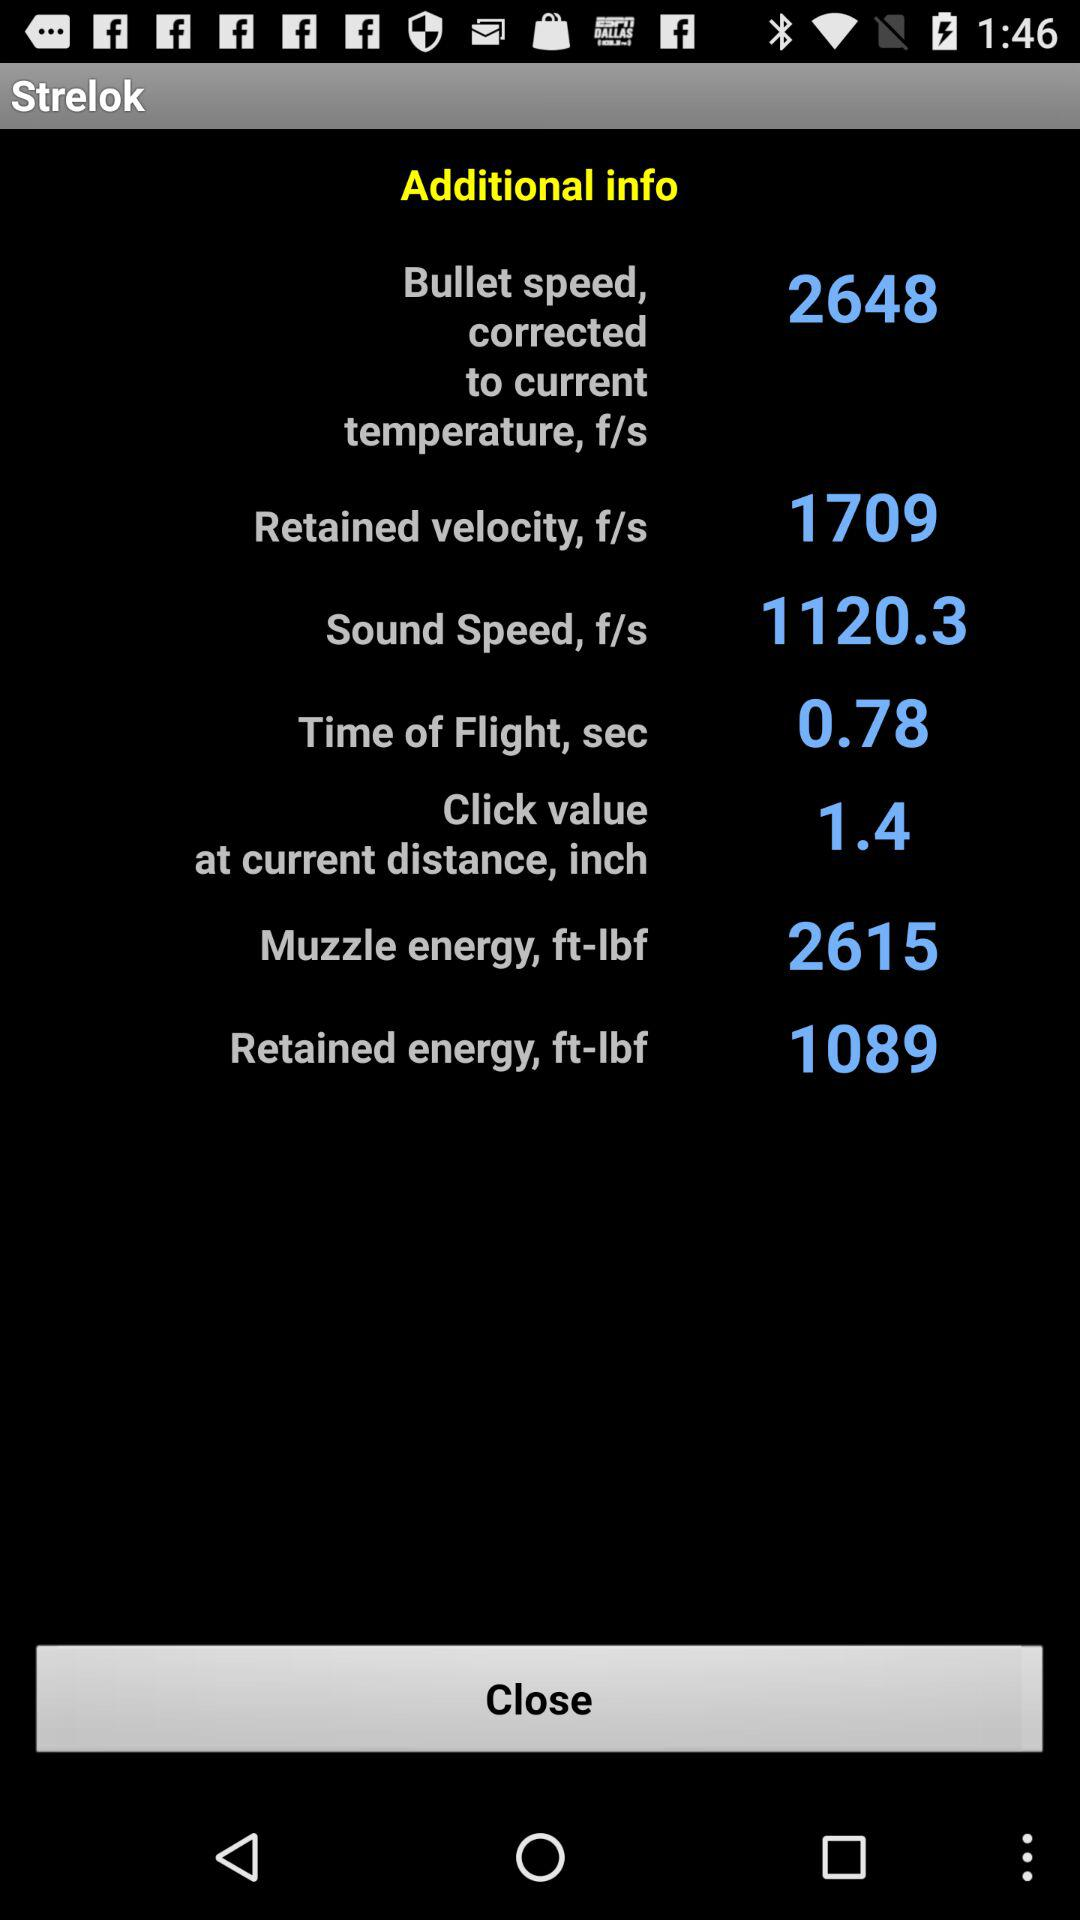What is the value of current?
When the provided information is insufficient, respond with <no answer>. <no answer> 